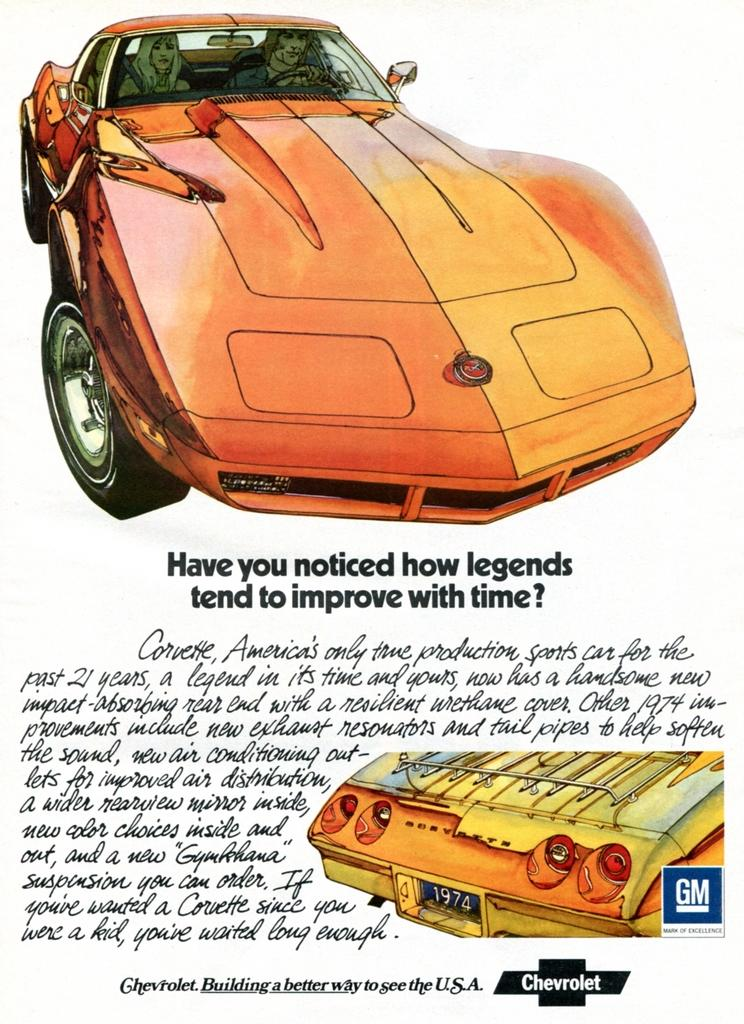What is depicted on the poster in the image? The poster contains vehicles and people. What else can be found on the poster besides the images? There is text on the poster. What is the color of the background in the image? The background of the image is white. How many clams are visible on the poster in the image? There are no clams present on the poster in the image. What type of current is flowing through the poster in the image? There is no current depicted on the poster in the image. 